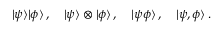Convert formula to latex. <formula><loc_0><loc_0><loc_500><loc_500>| \psi \rangle | \phi \rangle \, , \quad | \psi \rangle \otimes | \phi \rangle \, , \quad | \psi \phi \rangle \, , \quad | \psi , \phi \rangle \, .</formula> 